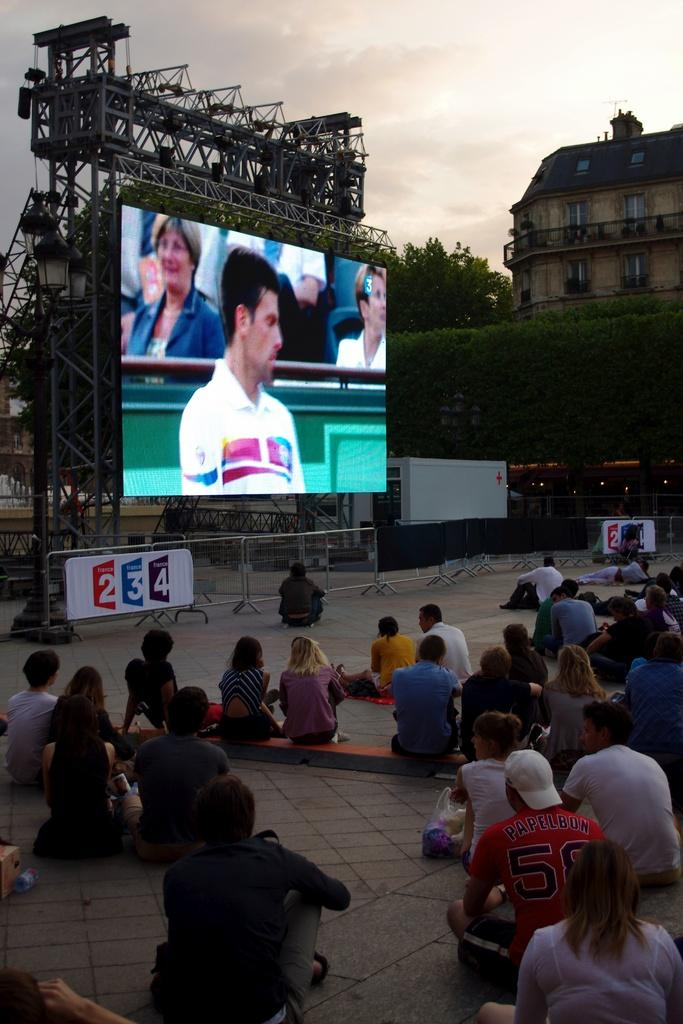<image>
Share a concise interpretation of the image provided. A crowd of people sit outside watching a large screen with number 234 below. 